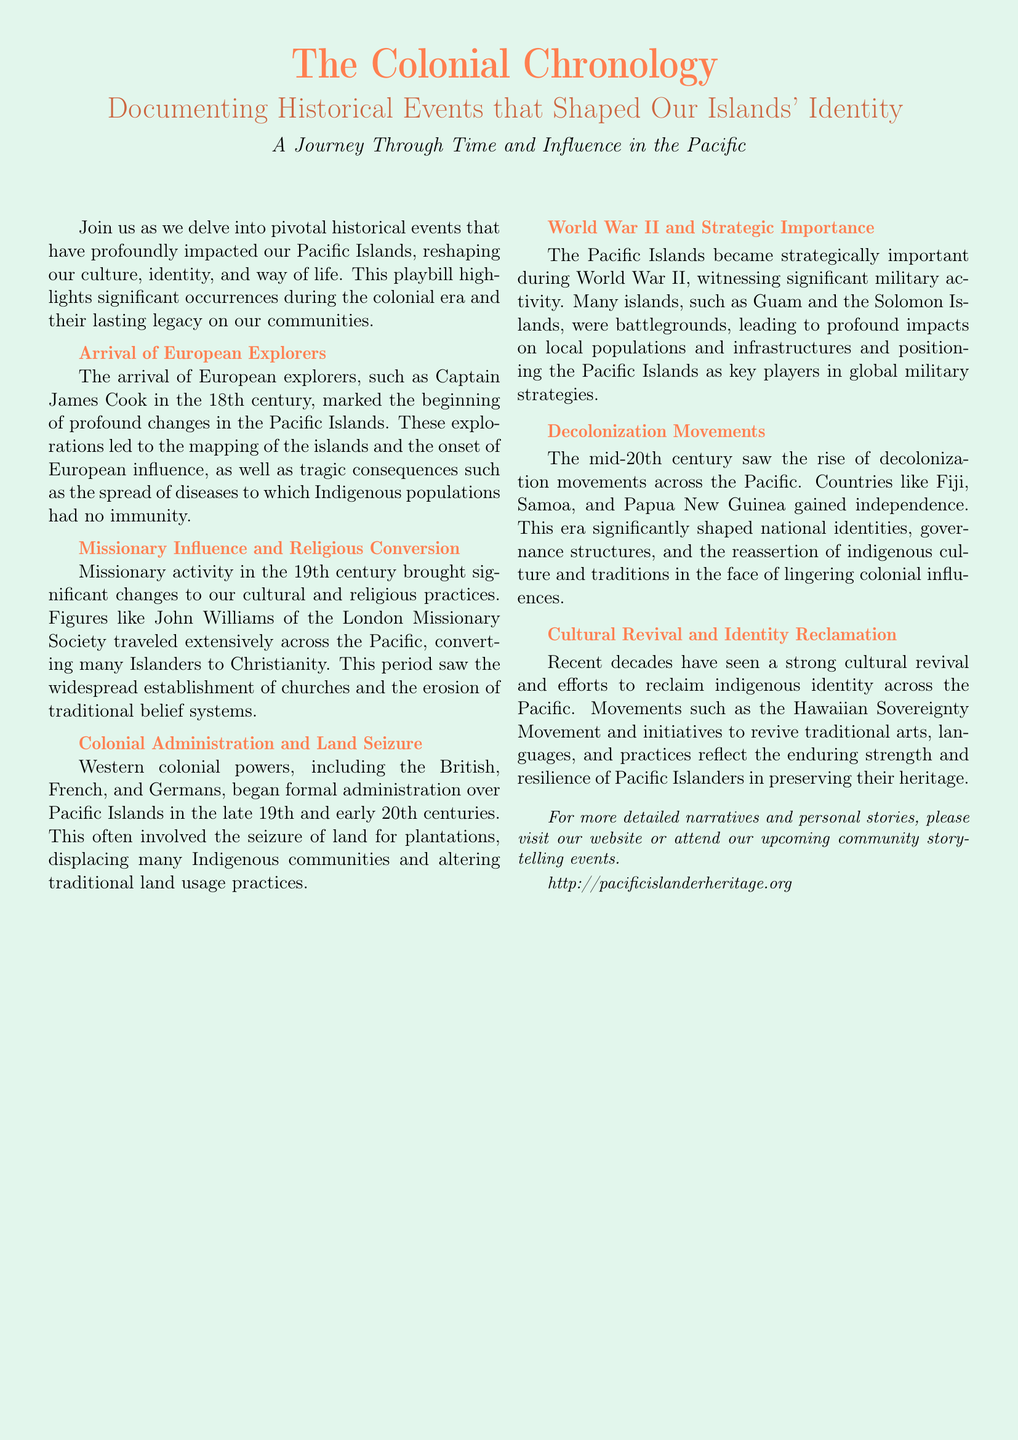What marked the beginning of profound changes in the Pacific Islands? The document mentions the arrival of European explorers, such as Captain James Cook in the 18th century, as the starting point for significant changes.
Answer: Arrival of European explorers Who was a key figure in missionary activity during the 19th century? The document highlights John Williams of the London Missionary Society as a significant individual in the context of missionary influence in the Pacific Islands.
Answer: John Williams In which century did decolonization movements rise across the Pacific? The document states that the mid-20th century is when decolonization movements became prominent in the Pacific region.
Answer: Mid-20th century What significant event turned the Pacific Islands into strategically important locations? According to the document, World War II is identified as the event that positioned the Pacific Islands strategically due to military activity.
Answer: World War II What initiative reflects the strength of Pacific Islanders in preserving their heritage? The document cites movements such as the Hawaiian Sovereignty Movement as initiatives that demonstrate the cultural revival and reclamation of identity in the Pacific Islands.
Answer: Hawaiian Sovereignty Movement What type of content does the playbill primarily document? The playbill focuses on documenting historical events that have shaped the identity of the Pacific Islands.
Answer: Historical events What is the purpose of the community storytelling events mentioned in the document? The document invites individuals to attend community storytelling events for more detailed narratives and personal stories related to the themes discussed.
Answer: Detailed narratives and personal stories 